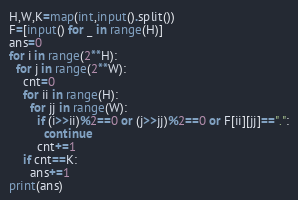Convert code to text. <code><loc_0><loc_0><loc_500><loc_500><_Python_>H,W,K=map(int,input().split())
F=[input() for _ in range(H)]
ans=0
for i in range(2**H):
  for j in range(2**W):
    cnt=0
    for ii in range(H):
      for jj in range(W):
        if (i>>ii)%2==0 or (j>>jj)%2==0 or F[ii][jj]==".":
          continue
        cnt+=1
    if cnt==K:
      ans+=1
print(ans)</code> 